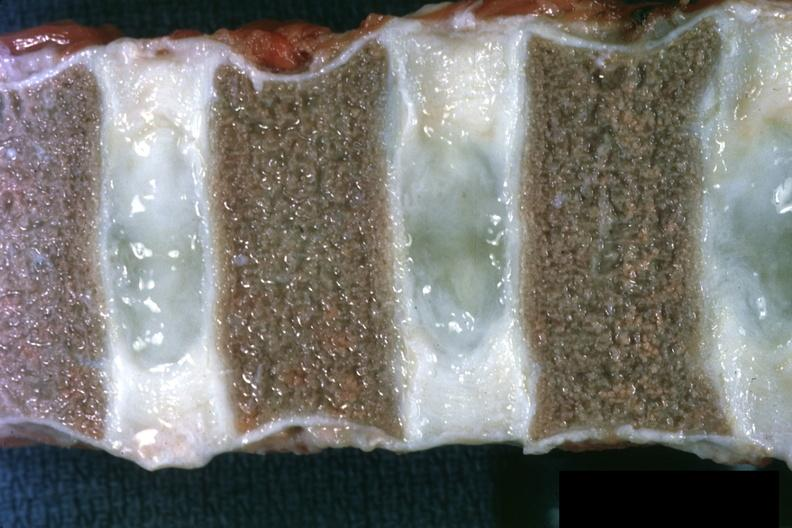what is present?
Answer the question using a single word or phrase. Chronic myelogenous leukemia 